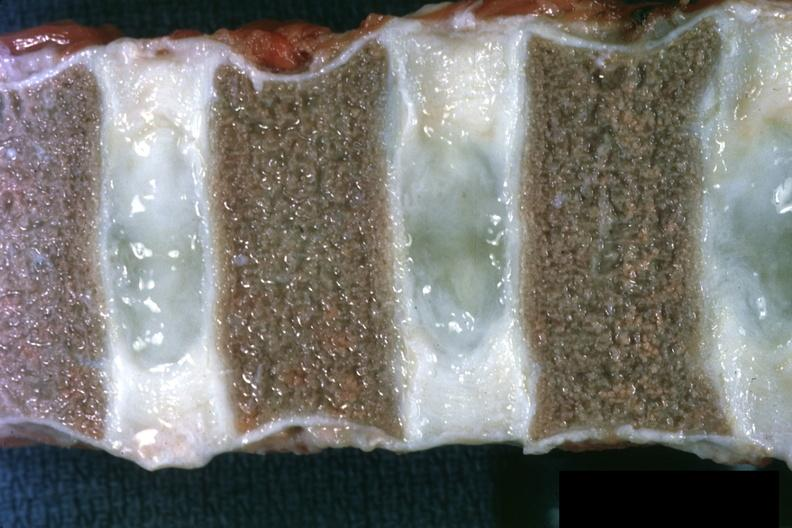what is present?
Answer the question using a single word or phrase. Chronic myelogenous leukemia 